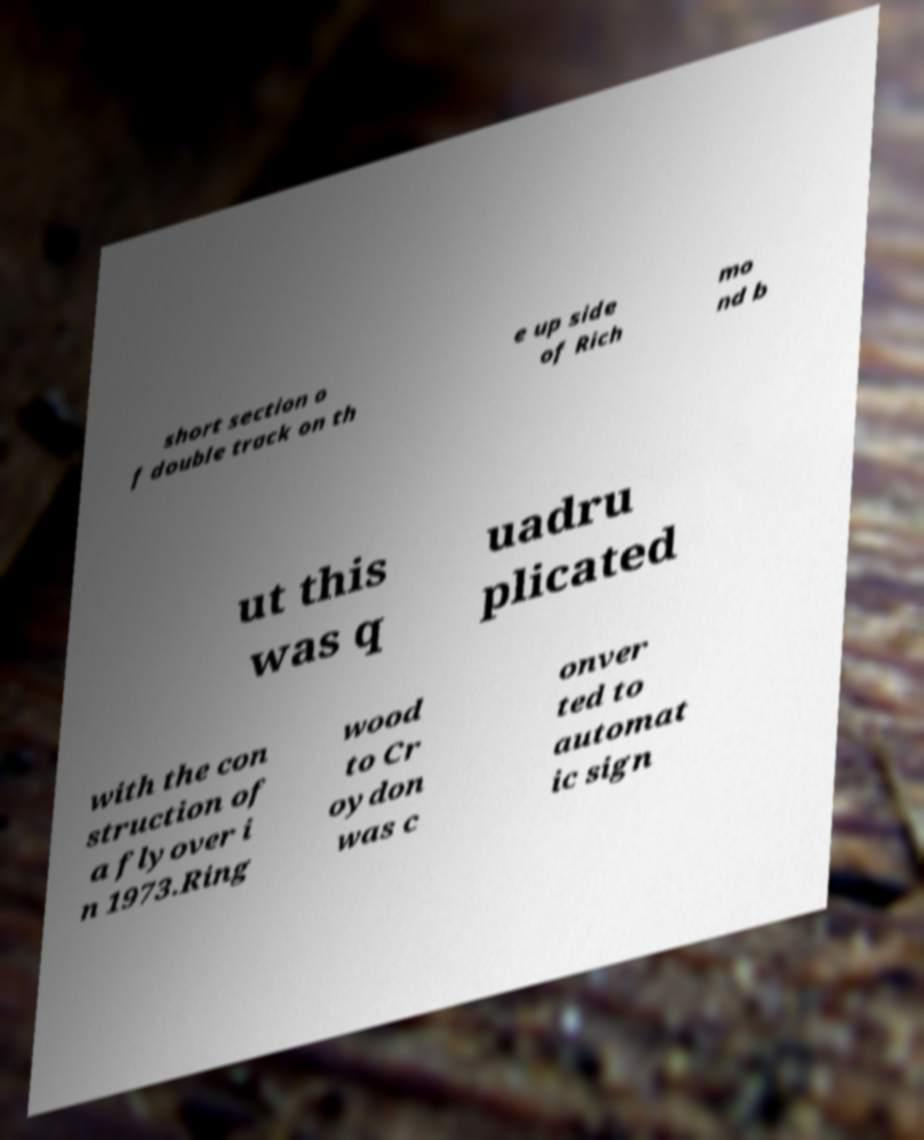For documentation purposes, I need the text within this image transcribed. Could you provide that? short section o f double track on th e up side of Rich mo nd b ut this was q uadru plicated with the con struction of a flyover i n 1973.Ring wood to Cr oydon was c onver ted to automat ic sign 